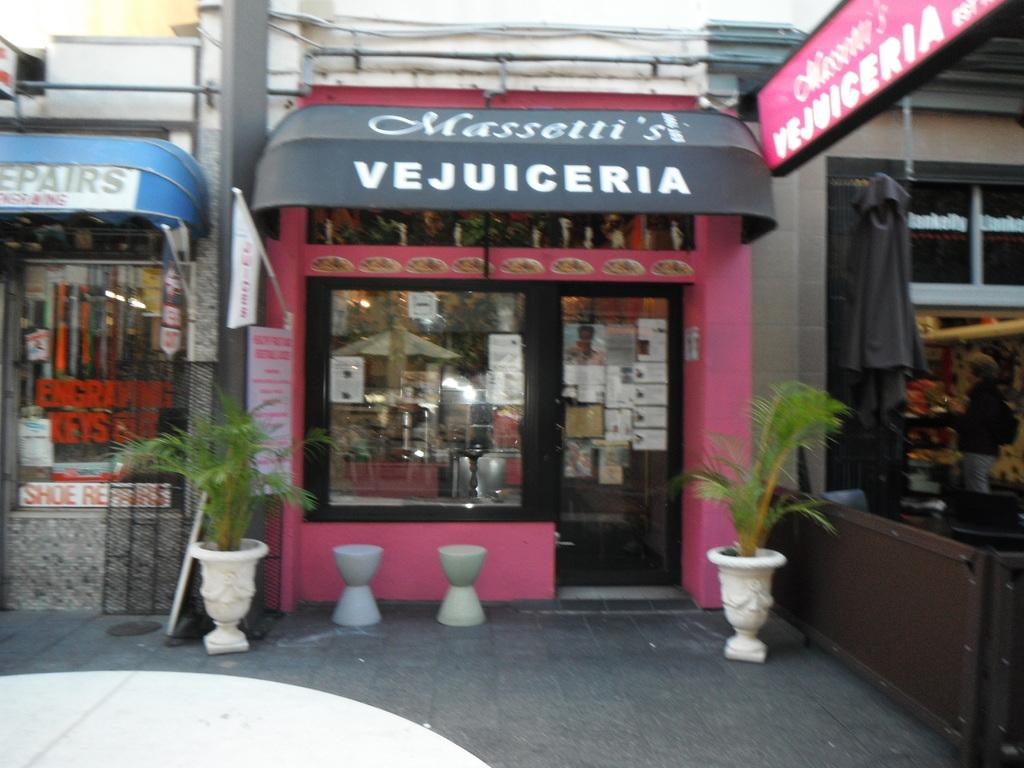What type of establishment is depicted in the image? There is a store front in the image. What color is the store? The store is pink in color. Are there any decorative elements inside the store? There are indoor plants on either side of the store. What is located next to the store in the image? There is another store beside the first store. Can you tell me how many clovers are growing in front of the store? There are no clovers visible in the image; it only shows a store front and an adjacent store. What type of wool is used to make the store's sign? There is no wool mentioned or visible in the image; the store's color is described as pink. 